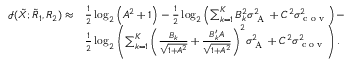Convert formula to latex. <formula><loc_0><loc_0><loc_500><loc_500>\begin{array} { r l } { \mathcal { I } ( { { { \tilde { X } } } } ; { { { \tilde { R } } } _ { 1 } } , { { R } _ { 2 } } ) \approx } & { \frac { 1 } { 2 } \log _ { 2 } \left ( { A ^ { 2 } + 1 } \right ) - \frac { 1 } { 2 } \log _ { 2 } \left ( { \sum _ { k = 1 } ^ { K } B _ { k } ^ { 2 } \sigma _ { A } ^ { 2 } + C ^ { 2 } \sigma _ { c o v } ^ { 2 } } \right ) - } \\ & { \frac { 1 } { 2 } \log _ { 2 } \left ( { { \sum _ { k = 1 } ^ { K } \left ( \frac { B _ { k } } { \sqrt { 1 + A ^ { 2 } } } + \frac { B _ { k } ^ { \prime } A } { \sqrt { 1 + A ^ { 2 } } } \right ) ^ { 2 } } \sigma _ { A } ^ { 2 } + C ^ { 2 } \sigma _ { c o v } ^ { 2 } } \right ) . } \end{array}</formula> 